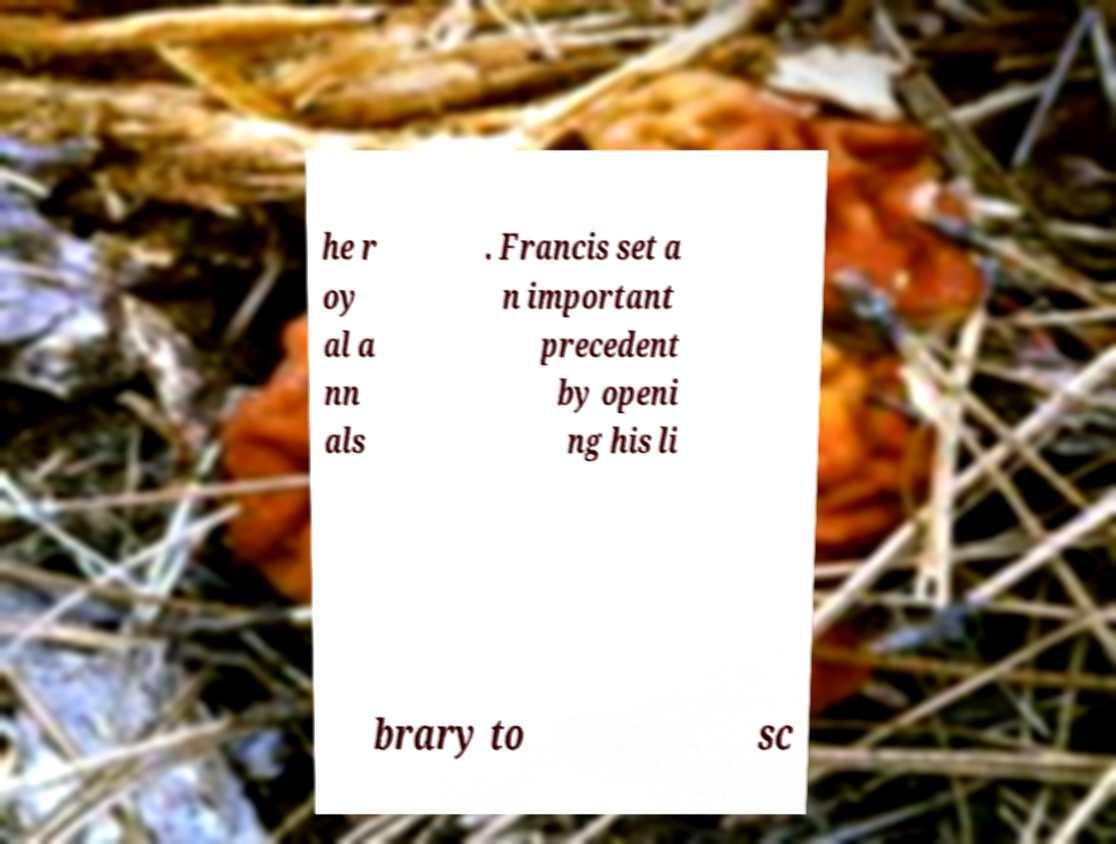I need the written content from this picture converted into text. Can you do that? he r oy al a nn als . Francis set a n important precedent by openi ng his li brary to sc 